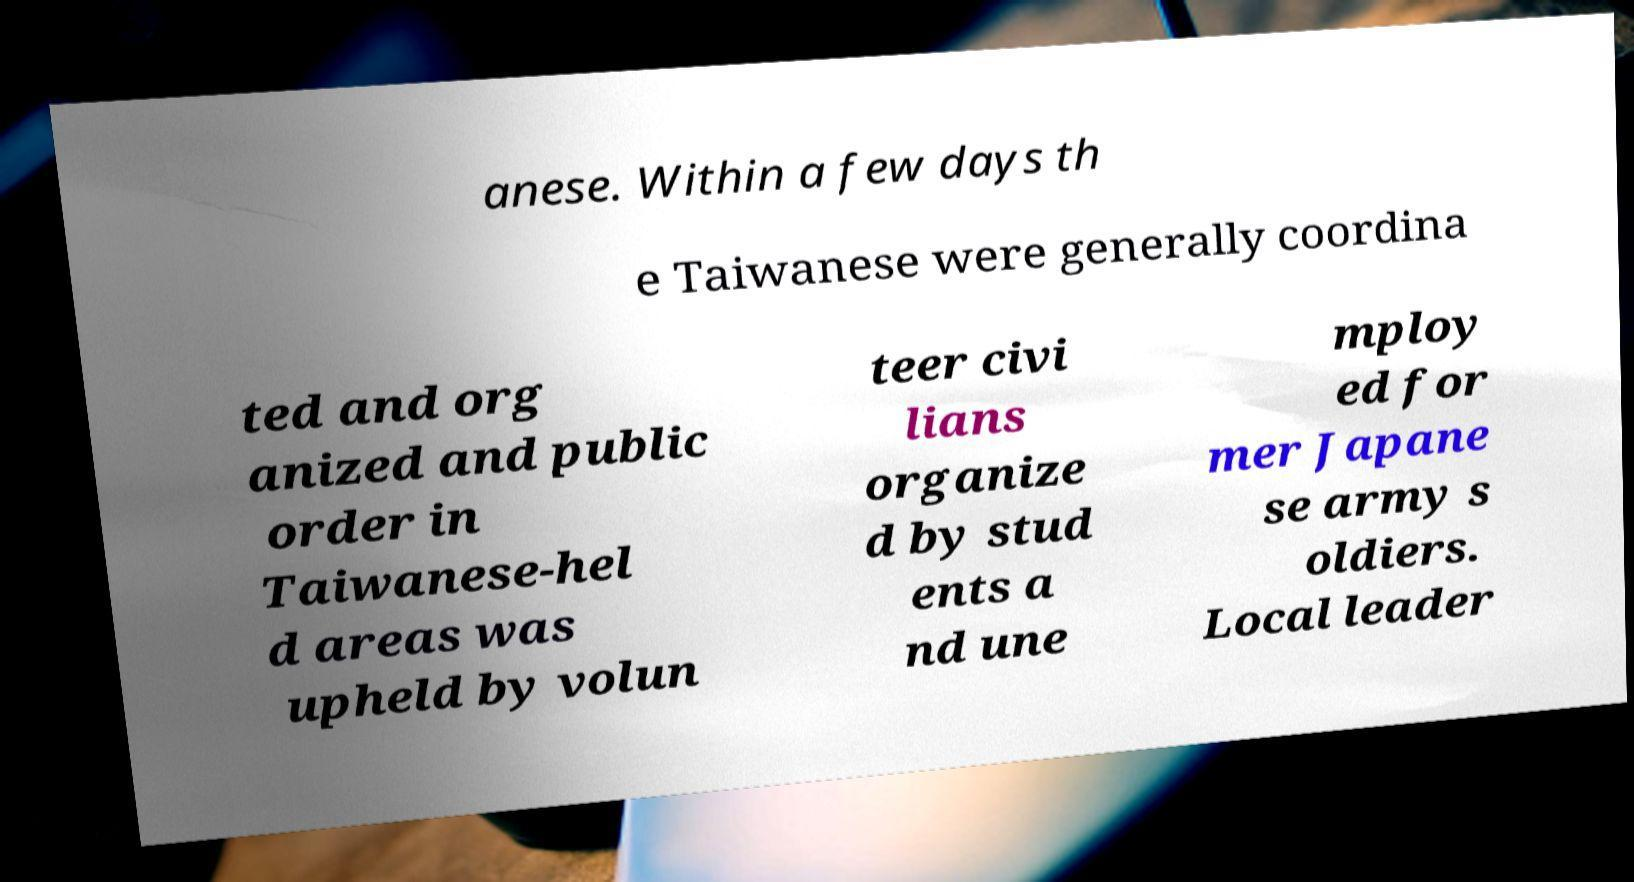There's text embedded in this image that I need extracted. Can you transcribe it verbatim? anese. Within a few days th e Taiwanese were generally coordina ted and org anized and public order in Taiwanese-hel d areas was upheld by volun teer civi lians organize d by stud ents a nd une mploy ed for mer Japane se army s oldiers. Local leader 